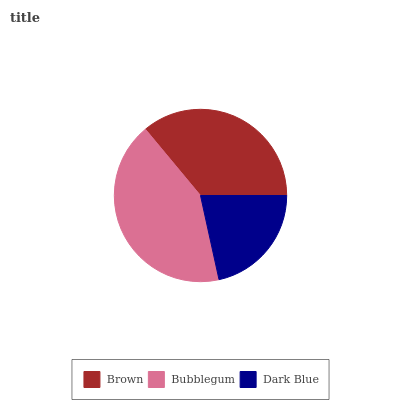Is Dark Blue the minimum?
Answer yes or no. Yes. Is Bubblegum the maximum?
Answer yes or no. Yes. Is Bubblegum the minimum?
Answer yes or no. No. Is Dark Blue the maximum?
Answer yes or no. No. Is Bubblegum greater than Dark Blue?
Answer yes or no. Yes. Is Dark Blue less than Bubblegum?
Answer yes or no. Yes. Is Dark Blue greater than Bubblegum?
Answer yes or no. No. Is Bubblegum less than Dark Blue?
Answer yes or no. No. Is Brown the high median?
Answer yes or no. Yes. Is Brown the low median?
Answer yes or no. Yes. Is Bubblegum the high median?
Answer yes or no. No. Is Bubblegum the low median?
Answer yes or no. No. 